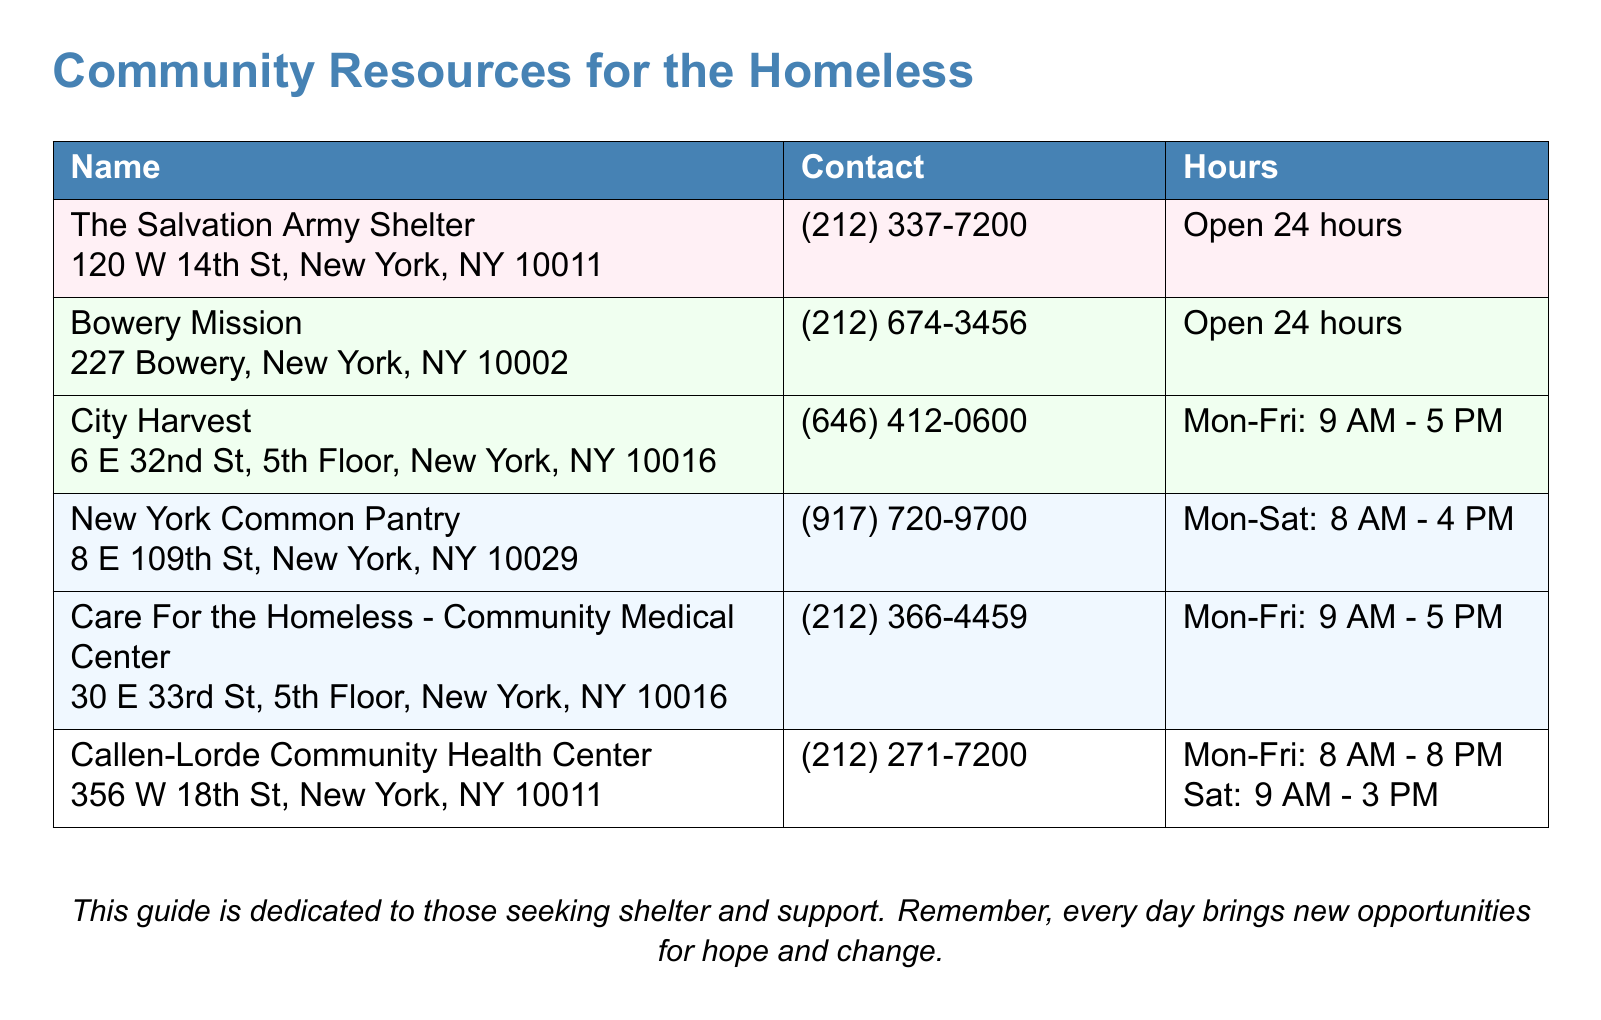What is the contact number for The Salvation Army Shelter? The contact number is provided in the document which lists each resource along with their contact details.
Answer: (212) 337-7200 What time does City Harvest open? The document includes the hours of operation for each resource listed, including opening times.
Answer: 9 AM How many health clinics are listed in the document? The document contains a section dedicated to health clinics, providing counts based on the provided resources.
Answer: 2 What is the address of Callen-Lorde Community Health Center? The addresses for each resource are listed in the document, allowing for easy retrieval of this information.
Answer: 356 W 18th St, New York, NY 10011 Which resource is open 24 hours? The document explicitly states the operating hours for each resource, highlighting those that are open around the clock.
Answer: The Salvation Army Shelter, Bowery Mission 